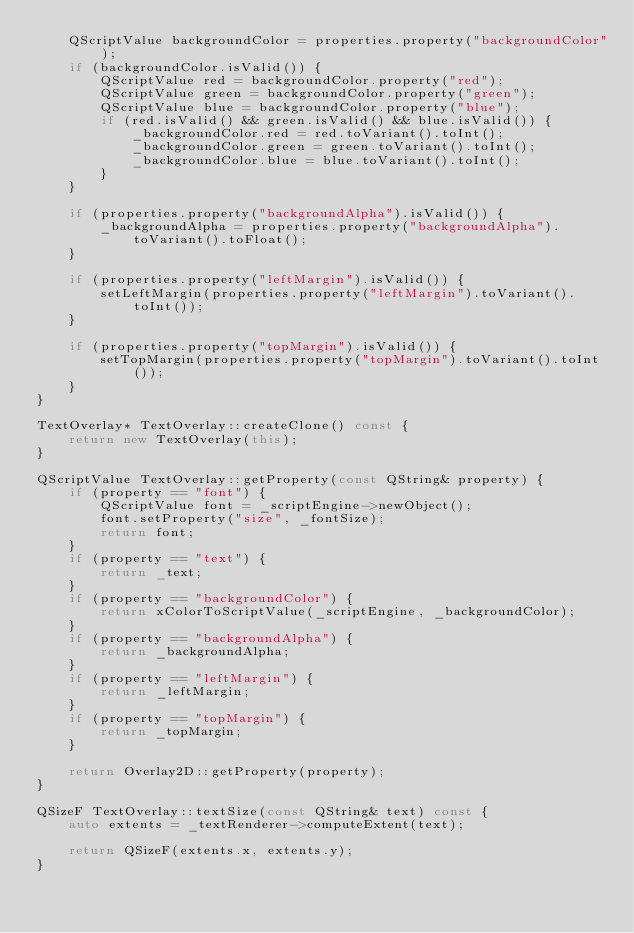Convert code to text. <code><loc_0><loc_0><loc_500><loc_500><_C++_>    QScriptValue backgroundColor = properties.property("backgroundColor");
    if (backgroundColor.isValid()) {
        QScriptValue red = backgroundColor.property("red");
        QScriptValue green = backgroundColor.property("green");
        QScriptValue blue = backgroundColor.property("blue");
        if (red.isValid() && green.isValid() && blue.isValid()) {
            _backgroundColor.red = red.toVariant().toInt();
            _backgroundColor.green = green.toVariant().toInt();
            _backgroundColor.blue = blue.toVariant().toInt();
        }
    }

    if (properties.property("backgroundAlpha").isValid()) {
        _backgroundAlpha = properties.property("backgroundAlpha").toVariant().toFloat();
    }

    if (properties.property("leftMargin").isValid()) {
        setLeftMargin(properties.property("leftMargin").toVariant().toInt());
    }

    if (properties.property("topMargin").isValid()) {
        setTopMargin(properties.property("topMargin").toVariant().toInt());
    }
}

TextOverlay* TextOverlay::createClone() const {
    return new TextOverlay(this);
}

QScriptValue TextOverlay::getProperty(const QString& property) {
    if (property == "font") {
        QScriptValue font = _scriptEngine->newObject();
        font.setProperty("size", _fontSize);
        return font;
    }
    if (property == "text") {
        return _text;
    }
    if (property == "backgroundColor") {
        return xColorToScriptValue(_scriptEngine, _backgroundColor);
    }
    if (property == "backgroundAlpha") {
        return _backgroundAlpha;
    }
    if (property == "leftMargin") {
        return _leftMargin;
    }
    if (property == "topMargin") {
        return _topMargin;
    }

    return Overlay2D::getProperty(property);
}

QSizeF TextOverlay::textSize(const QString& text) const {
    auto extents = _textRenderer->computeExtent(text);

    return QSizeF(extents.x, extents.y);
}
</code> 